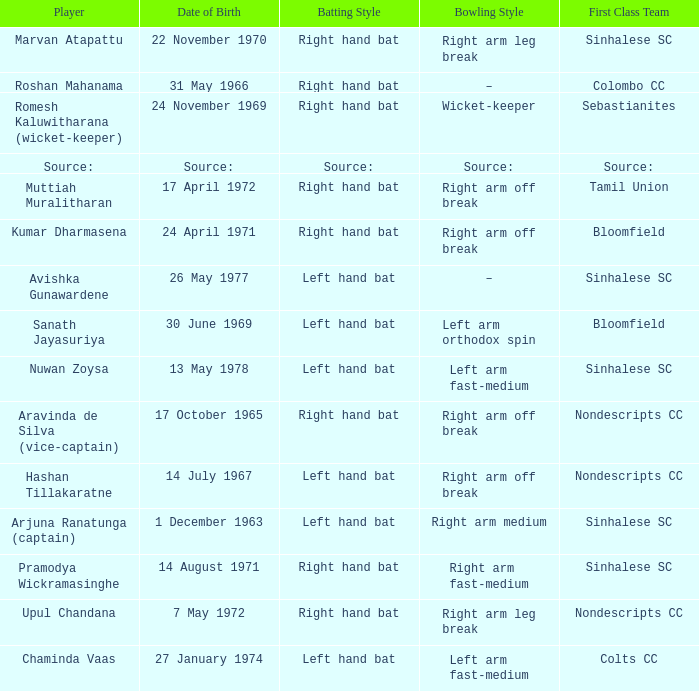When was avishka gunawardene born? 26 May 1977. Would you mind parsing the complete table? {'header': ['Player', 'Date of Birth', 'Batting Style', 'Bowling Style', 'First Class Team'], 'rows': [['Marvan Atapattu', '22 November 1970', 'Right hand bat', 'Right arm leg break', 'Sinhalese SC'], ['Roshan Mahanama', '31 May 1966', 'Right hand bat', '–', 'Colombo CC'], ['Romesh Kaluwitharana (wicket-keeper)', '24 November 1969', 'Right hand bat', 'Wicket-keeper', 'Sebastianites'], ['Source:', 'Source:', 'Source:', 'Source:', 'Source:'], ['Muttiah Muralitharan', '17 April 1972', 'Right hand bat', 'Right arm off break', 'Tamil Union'], ['Kumar Dharmasena', '24 April 1971', 'Right hand bat', 'Right arm off break', 'Bloomfield'], ['Avishka Gunawardene', '26 May 1977', 'Left hand bat', '–', 'Sinhalese SC'], ['Sanath Jayasuriya', '30 June 1969', 'Left hand bat', 'Left arm orthodox spin', 'Bloomfield'], ['Nuwan Zoysa', '13 May 1978', 'Left hand bat', 'Left arm fast-medium', 'Sinhalese SC'], ['Aravinda de Silva (vice-captain)', '17 October 1965', 'Right hand bat', 'Right arm off break', 'Nondescripts CC'], ['Hashan Tillakaratne', '14 July 1967', 'Left hand bat', 'Right arm off break', 'Nondescripts CC'], ['Arjuna Ranatunga (captain)', '1 December 1963', 'Left hand bat', 'Right arm medium', 'Sinhalese SC'], ['Pramodya Wickramasinghe', '14 August 1971', 'Right hand bat', 'Right arm fast-medium', 'Sinhalese SC'], ['Upul Chandana', '7 May 1972', 'Right hand bat', 'Right arm leg break', 'Nondescripts CC'], ['Chaminda Vaas', '27 January 1974', 'Left hand bat', 'Left arm fast-medium', 'Colts CC']]} 